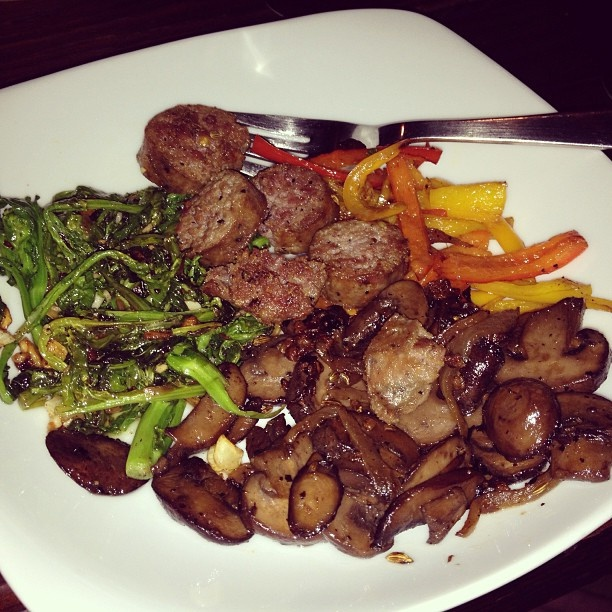Describe the objects in this image and their specific colors. I can see dining table in beige, black, maroon, lightgray, and brown tones, fork in purple, black, darkgray, gray, and maroon tones, broccoli in purple, black, olive, maroon, and gray tones, and broccoli in purple, darkgreen, black, and olive tones in this image. 